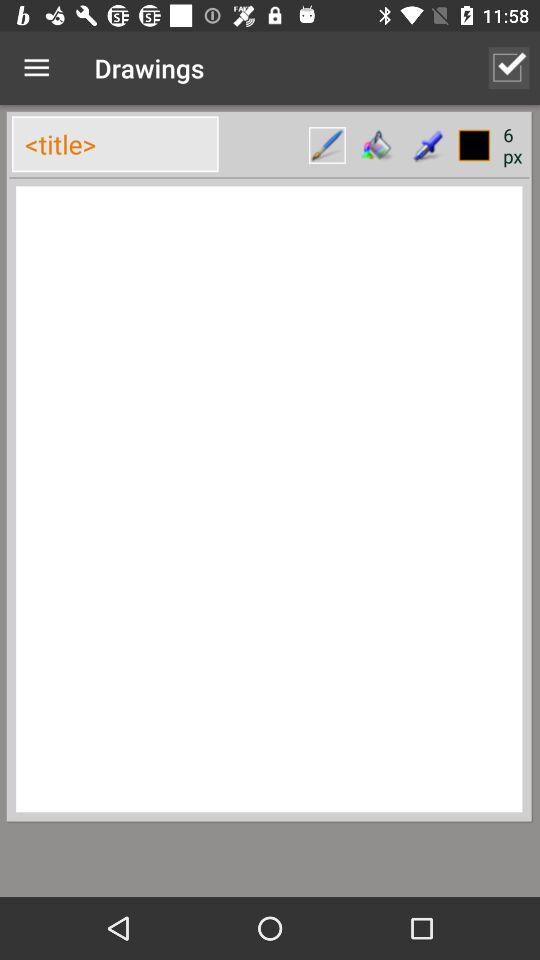What is the used number of pixels? The used number of pixels is 6. 